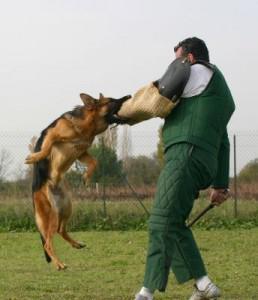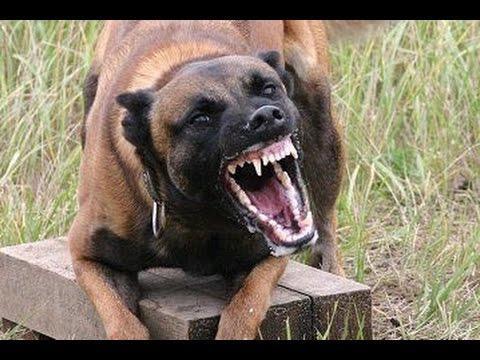The first image is the image on the left, the second image is the image on the right. For the images shown, is this caption "At least one dog is biting someone." true? Answer yes or no. Yes. 